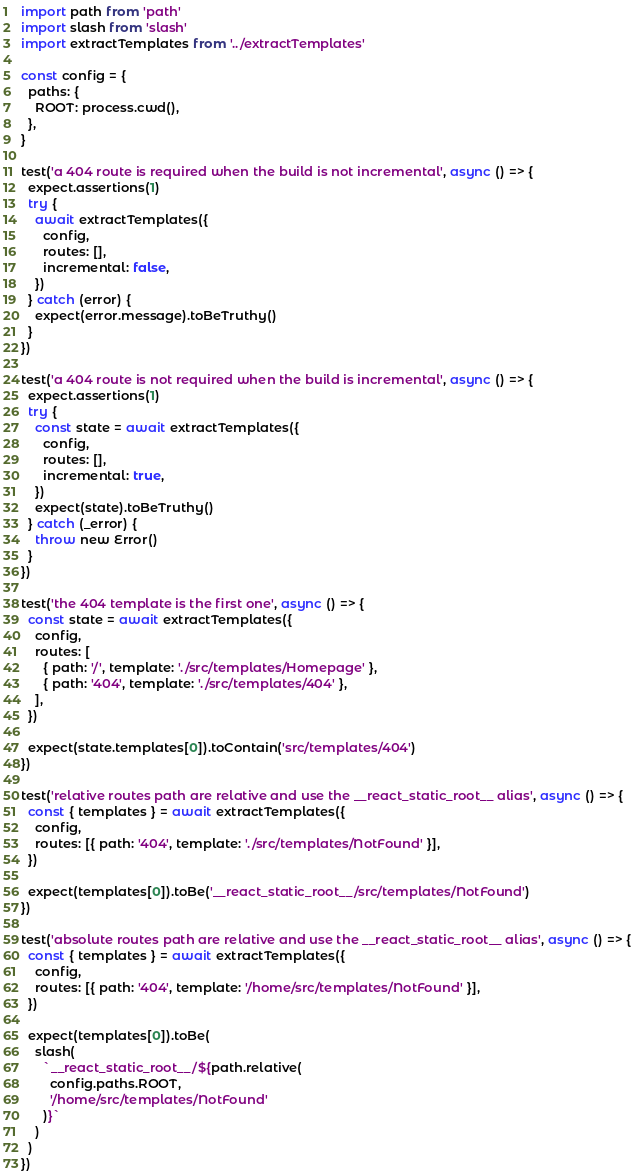<code> <loc_0><loc_0><loc_500><loc_500><_JavaScript_>import path from 'path'
import slash from 'slash'
import extractTemplates from '../extractTemplates'

const config = {
  paths: {
    ROOT: process.cwd(),
  },
}

test('a 404 route is required when the build is not incremental', async () => {
  expect.assertions(1)
  try {
    await extractTemplates({
      config,
      routes: [],
      incremental: false,
    })
  } catch (error) {
    expect(error.message).toBeTruthy()
  }
})

test('a 404 route is not required when the build is incremental', async () => {
  expect.assertions(1)
  try {
    const state = await extractTemplates({
      config,
      routes: [],
      incremental: true,
    })
    expect(state).toBeTruthy()
  } catch (_error) {
    throw new Error()
  }
})

test('the 404 template is the first one', async () => {
  const state = await extractTemplates({
    config,
    routes: [
      { path: '/', template: './src/templates/Homepage' },
      { path: '404', template: './src/templates/404' },
    ],
  })

  expect(state.templates[0]).toContain('src/templates/404')
})

test('relative routes path are relative and use the __react_static_root__ alias', async () => {
  const { templates } = await extractTemplates({
    config,
    routes: [{ path: '404', template: './src/templates/NotFound' }],
  })

  expect(templates[0]).toBe('__react_static_root__/src/templates/NotFound')
})

test('absolute routes path are relative and use the __react_static_root__ alias', async () => {
  const { templates } = await extractTemplates({
    config,
    routes: [{ path: '404', template: '/home/src/templates/NotFound' }],
  })

  expect(templates[0]).toBe(
    slash(
      `__react_static_root__/${path.relative(
        config.paths.ROOT,
        '/home/src/templates/NotFound'
      )}`
    )
  )
})
</code> 